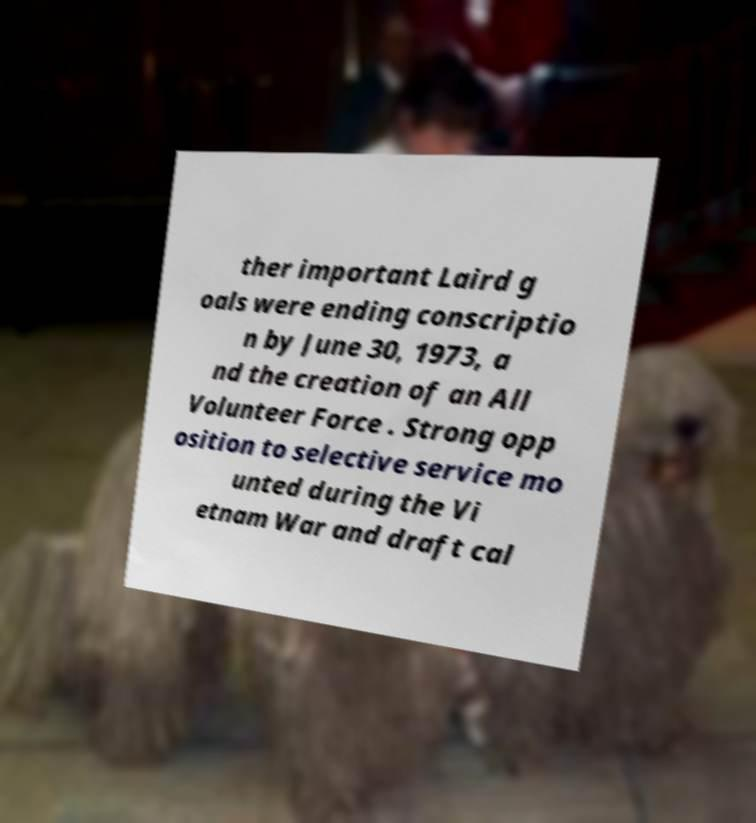Could you assist in decoding the text presented in this image and type it out clearly? ther important Laird g oals were ending conscriptio n by June 30, 1973, a nd the creation of an All Volunteer Force . Strong opp osition to selective service mo unted during the Vi etnam War and draft cal 